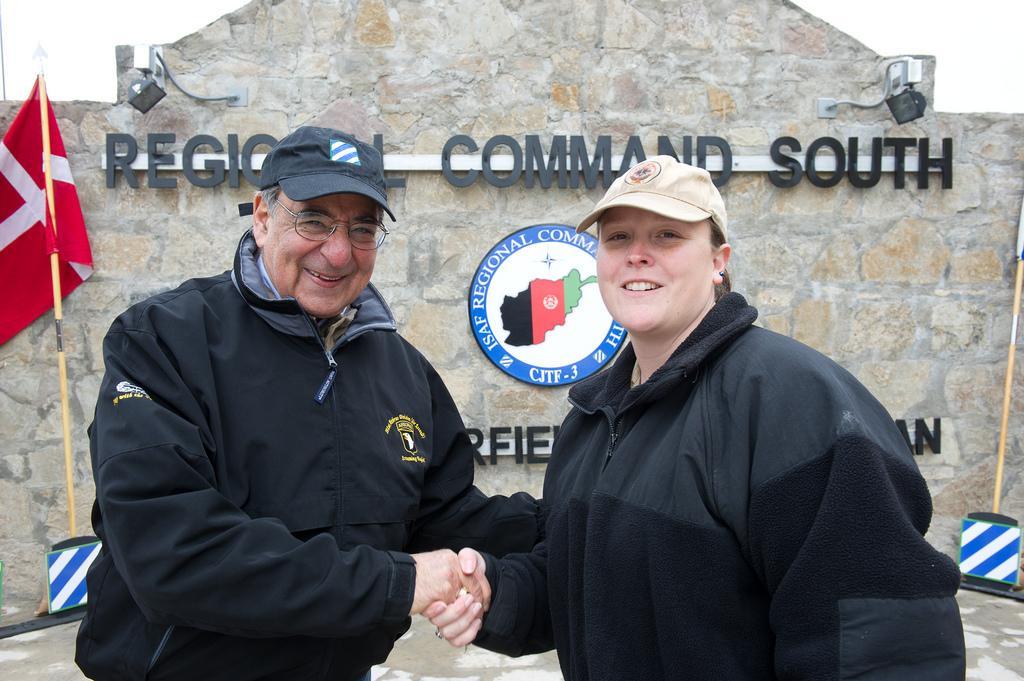Please provide a concise description of this image. In this image I can see two persons wearing black colored jackets and hats are standing and shaking hands with each other. In the background I can see the rock wall, a red and white colored flag, two lights and the white colored sky. 